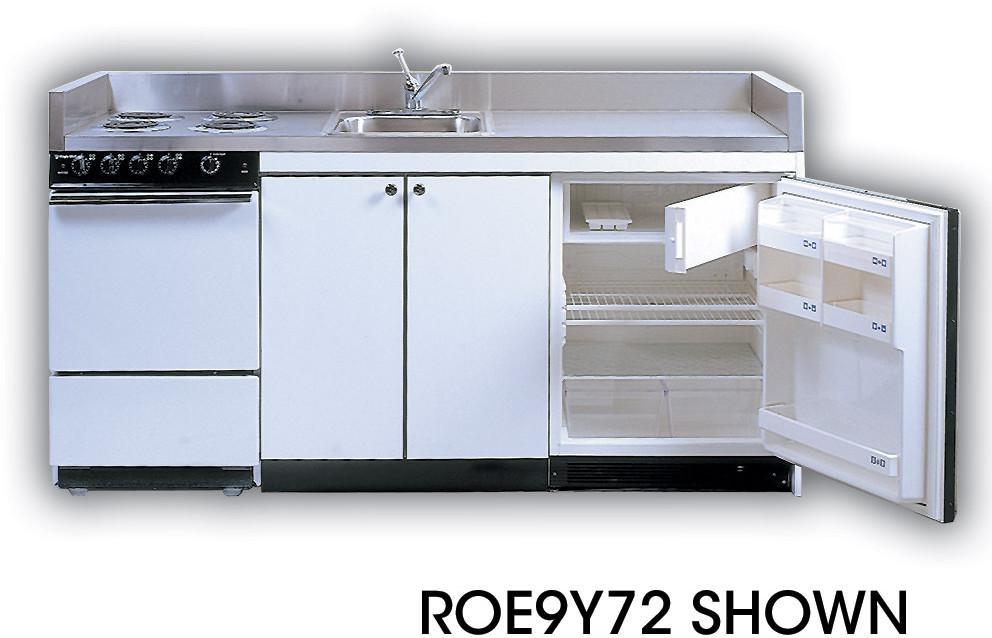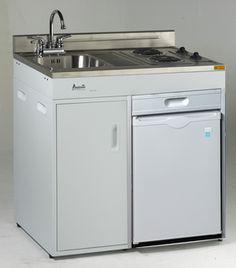The first image is the image on the left, the second image is the image on the right. Assess this claim about the two images: "One refrigerator door is all the way wide open and the door shelves are showing.". Correct or not? Answer yes or no. Yes. The first image is the image on the left, the second image is the image on the right. For the images displayed, is the sentence "Only one refrigerator has its door open, and it has no contents within." factually correct? Answer yes or no. Yes. 